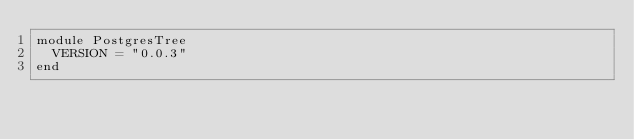<code> <loc_0><loc_0><loc_500><loc_500><_Ruby_>module PostgresTree
  VERSION = "0.0.3"
end
</code> 